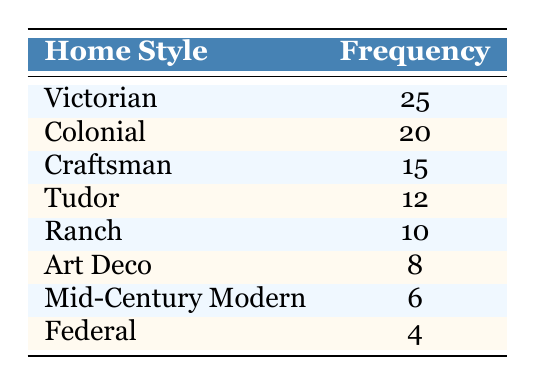What is the most common home style in the historical districts? The table indicates that the Victorian style has the highest frequency of 25, making it the most common home style.
Answer: Victorian How many styles have a frequency of 10 or more? The styles with a frequency of 10 or more are Victorian (25), Colonial (20), Craftsman (15), Tudor (12), and Ranch (10). This totals five styles.
Answer: 5 Is there a home style that has a frequency of 8? The table shows that Art Deco has a frequency of 8.
Answer: Yes What is the total frequency of all home styles listed? To find the total frequency, we sum all individual frequencies: 25 + 20 + 15 + 10 + 8 + 12 + 6 + 4 = 100.
Answer: 100 Which home style has the lowest frequency? According to the table, the Federal style has the lowest frequency, which is 4.
Answer: Federal What is the difference in frequency between the Victorian and Colonial home styles? The frequency of Victorian is 25 and Colonial is 20. The difference is 25 - 20 = 5.
Answer: 5 If we combine the frequencies of the Craftsman and Tudor styles, what is the sum? The frequency for Craftsman is 15 and Tudor is 12. Their combined frequency is 15 + 12 = 27.
Answer: 27 Do more than half of the home styles listed have a frequency less than 10? The styles with a frequency less than 10 are Art Deco (8), Mid-Century Modern (6), and Federal (4), which totals three styles out of eight. This does not make up more than half.
Answer: No What is the average frequency of the home styles in the table? To find the average, add all frequencies (100) and divide by the number of styles (8). The average is 100/8 = 12.5.
Answer: 12.5 